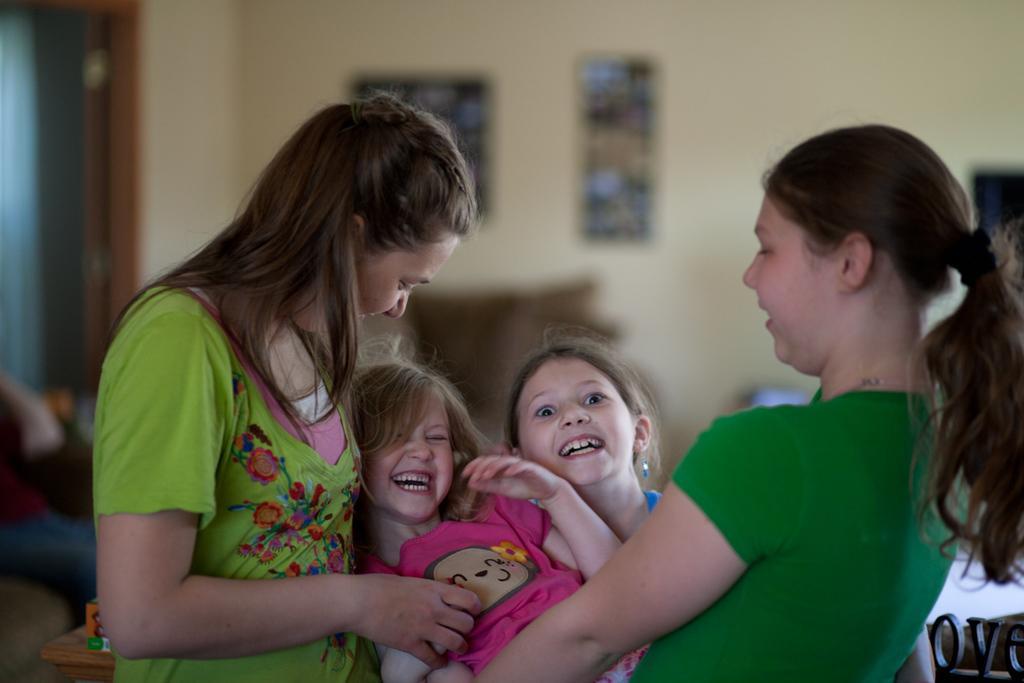How would you summarize this image in a sentence or two? In this picture we can see few people and we can find few frames on the wall, also we can see blurry background. 